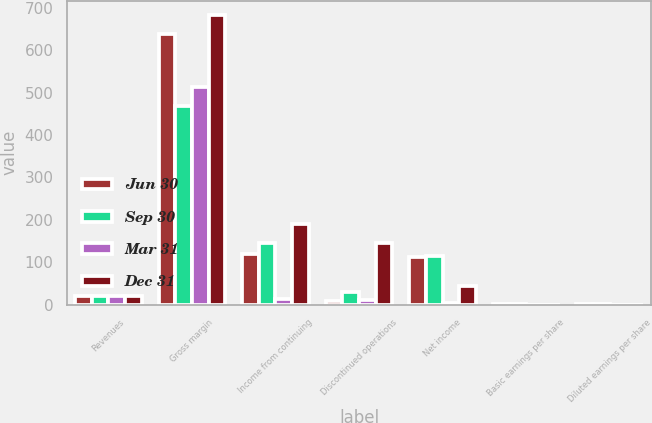Convert chart to OTSL. <chart><loc_0><loc_0><loc_500><loc_500><stacked_bar_chart><ecel><fcel>Revenues<fcel>Gross margin<fcel>Income from continuing<fcel>Discontinued operations<fcel>Net income<fcel>Basic earnings per share<fcel>Diluted earnings per share<nl><fcel>Jun 30<fcel>21<fcel>637<fcel>120<fcel>9<fcel>111<fcel>0.21<fcel>0.2<nl><fcel>Sep 30<fcel>21<fcel>469<fcel>144<fcel>29<fcel>115<fcel>0.22<fcel>0.22<nl><fcel>Mar 31<fcel>21<fcel>514<fcel>13<fcel>10<fcel>3<fcel>0<fcel>0<nl><fcel>Dec 31<fcel>21<fcel>682<fcel>190<fcel>146<fcel>44<fcel>0.09<fcel>0.08<nl></chart> 